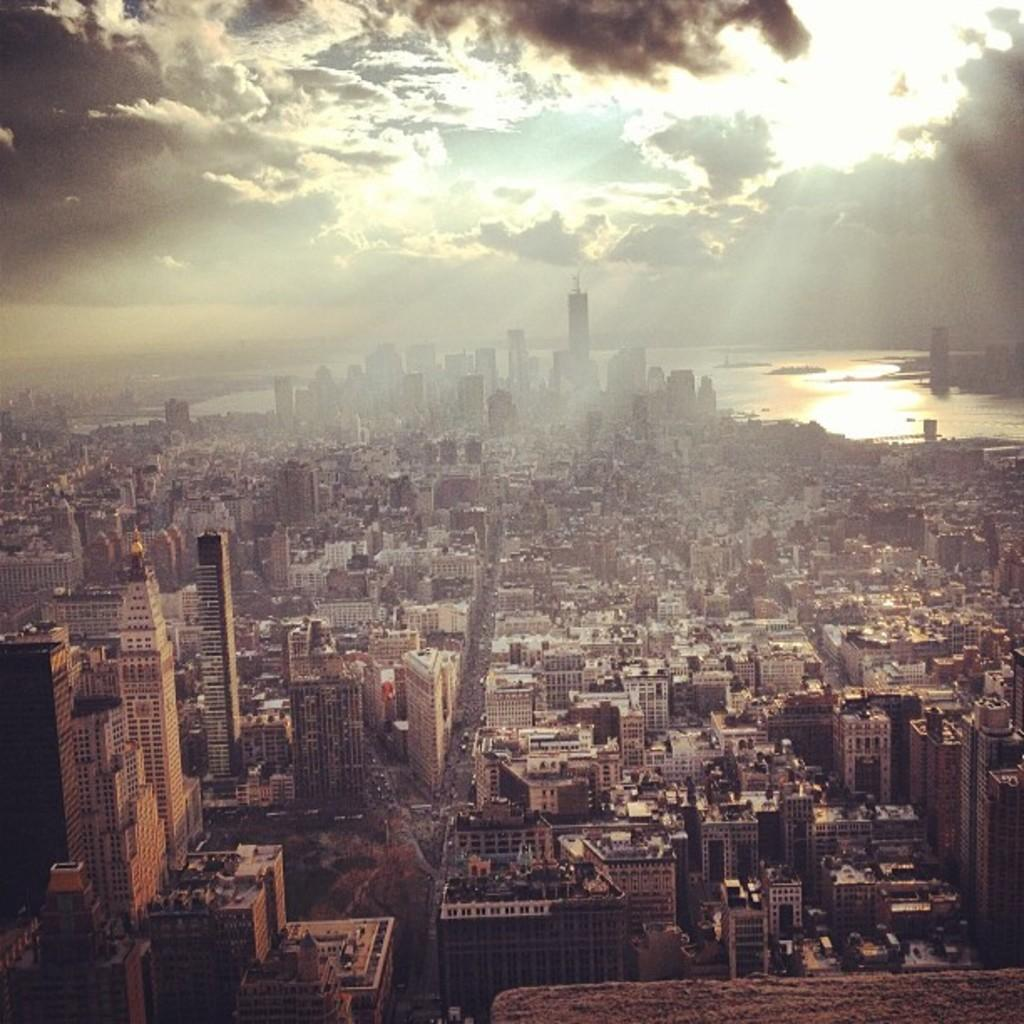What type of structures can be seen in the image? There are buildings in the image. What is present on the ground in the image? There is a road in the image, and vehicles are on the road. What can be seen in the background of the image? There is water, buildings, and the sky visible in the background of the image. Can the sun be seen in the image? Yes, the sun is observable in the sky. What type of nest can be seen in the image? There is no nest present in the image. Can you identify any actors in the image? There are no actors present in the image. 